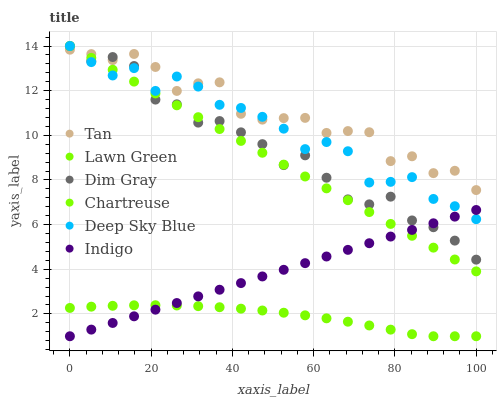Does Lawn Green have the minimum area under the curve?
Answer yes or no. Yes. Does Tan have the maximum area under the curve?
Answer yes or no. Yes. Does Dim Gray have the minimum area under the curve?
Answer yes or no. No. Does Dim Gray have the maximum area under the curve?
Answer yes or no. No. Is Indigo the smoothest?
Answer yes or no. Yes. Is Tan the roughest?
Answer yes or no. Yes. Is Dim Gray the smoothest?
Answer yes or no. No. Is Dim Gray the roughest?
Answer yes or no. No. Does Lawn Green have the lowest value?
Answer yes or no. Yes. Does Dim Gray have the lowest value?
Answer yes or no. No. Does Deep Sky Blue have the highest value?
Answer yes or no. Yes. Does Indigo have the highest value?
Answer yes or no. No. Is Indigo less than Tan?
Answer yes or no. Yes. Is Dim Gray greater than Lawn Green?
Answer yes or no. Yes. Does Dim Gray intersect Tan?
Answer yes or no. Yes. Is Dim Gray less than Tan?
Answer yes or no. No. Is Dim Gray greater than Tan?
Answer yes or no. No. Does Indigo intersect Tan?
Answer yes or no. No. 